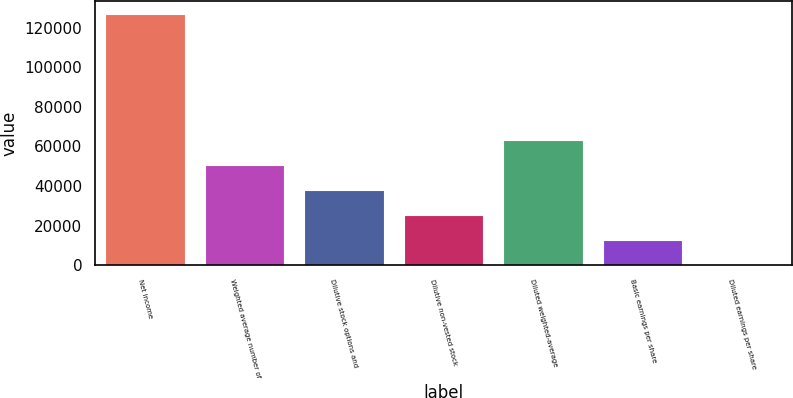<chart> <loc_0><loc_0><loc_500><loc_500><bar_chart><fcel>Net income<fcel>Weighted average number of<fcel>Dilutive stock options and<fcel>Dilutive non-vested stock<fcel>Diluted weighted-average<fcel>Basic earnings per share<fcel>Diluted earnings per share<nl><fcel>126845<fcel>50740.4<fcel>38056.3<fcel>25372.2<fcel>63424.5<fcel>12688.1<fcel>3.95<nl></chart> 